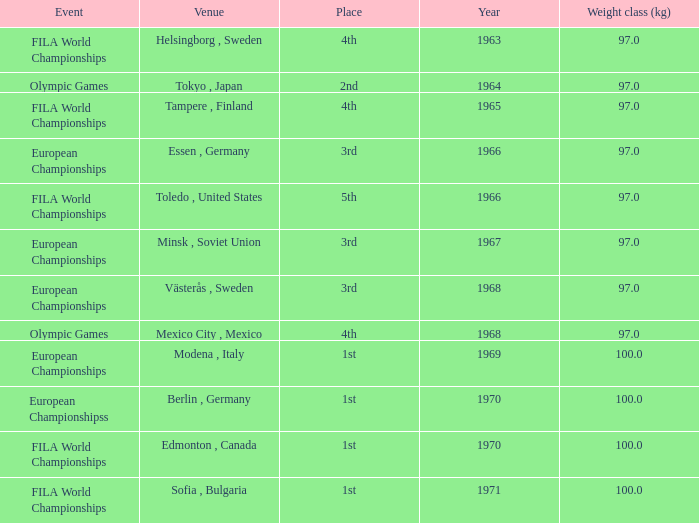What is the lowest weight class (kg) that has sofia, bulgaria as the venue? 100.0. 